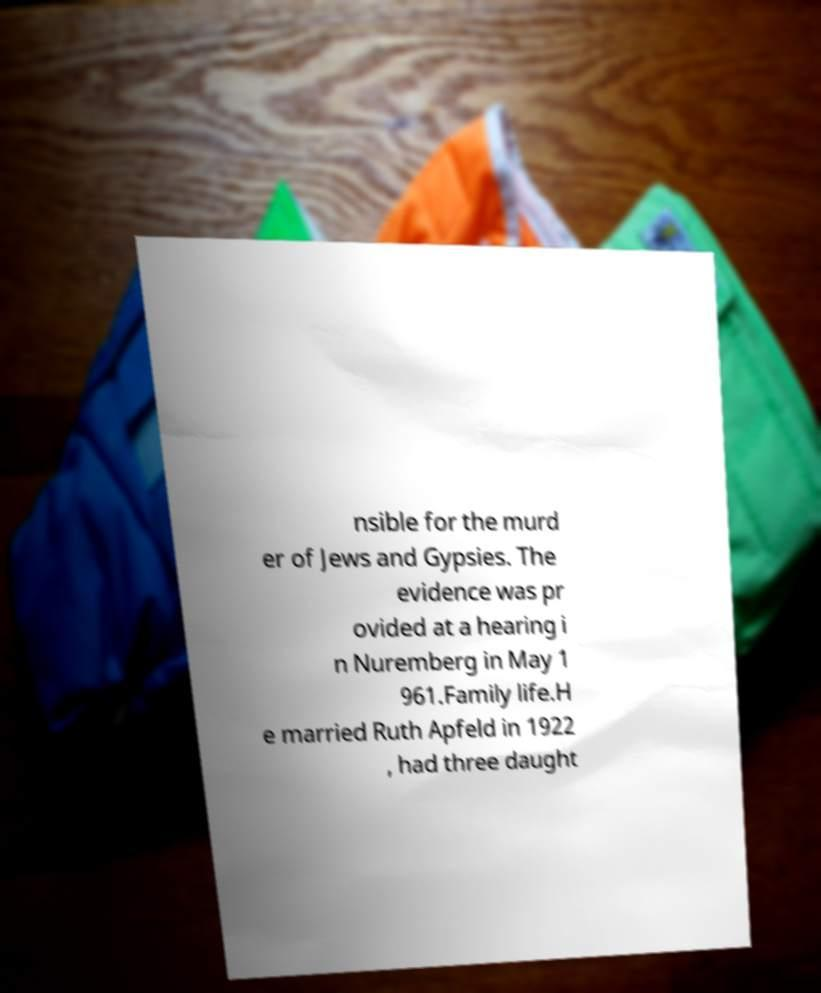Can you read and provide the text displayed in the image?This photo seems to have some interesting text. Can you extract and type it out for me? nsible for the murd er of Jews and Gypsies. The evidence was pr ovided at a hearing i n Nuremberg in May 1 961.Family life.H e married Ruth Apfeld in 1922 , had three daught 